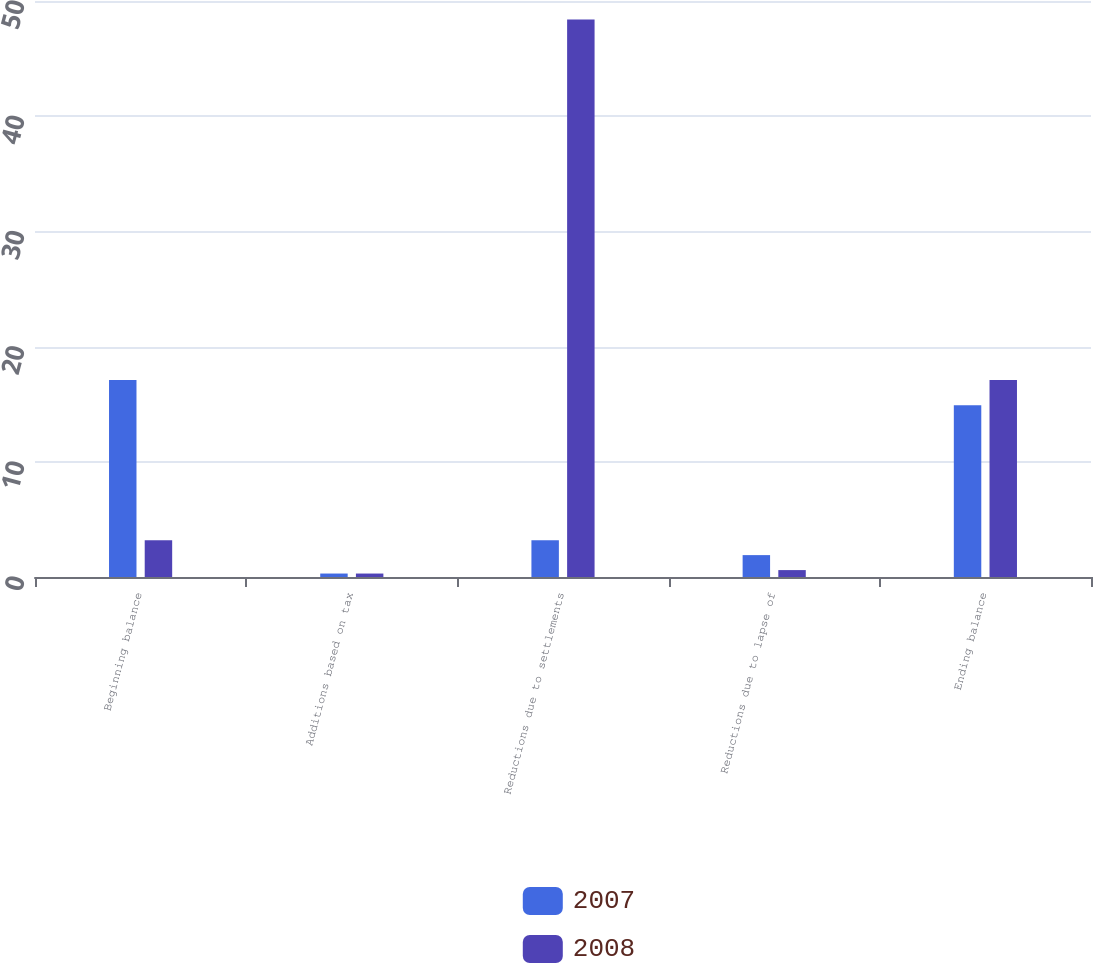<chart> <loc_0><loc_0><loc_500><loc_500><stacked_bar_chart><ecel><fcel>Beginning balance<fcel>Additions based on tax<fcel>Reductions due to settlements<fcel>Reductions due to lapse of<fcel>Ending balance<nl><fcel>2007<fcel>17.1<fcel>0.3<fcel>3.2<fcel>1.9<fcel>14.9<nl><fcel>2008<fcel>3.2<fcel>0.3<fcel>48.4<fcel>0.6<fcel>17.1<nl></chart> 